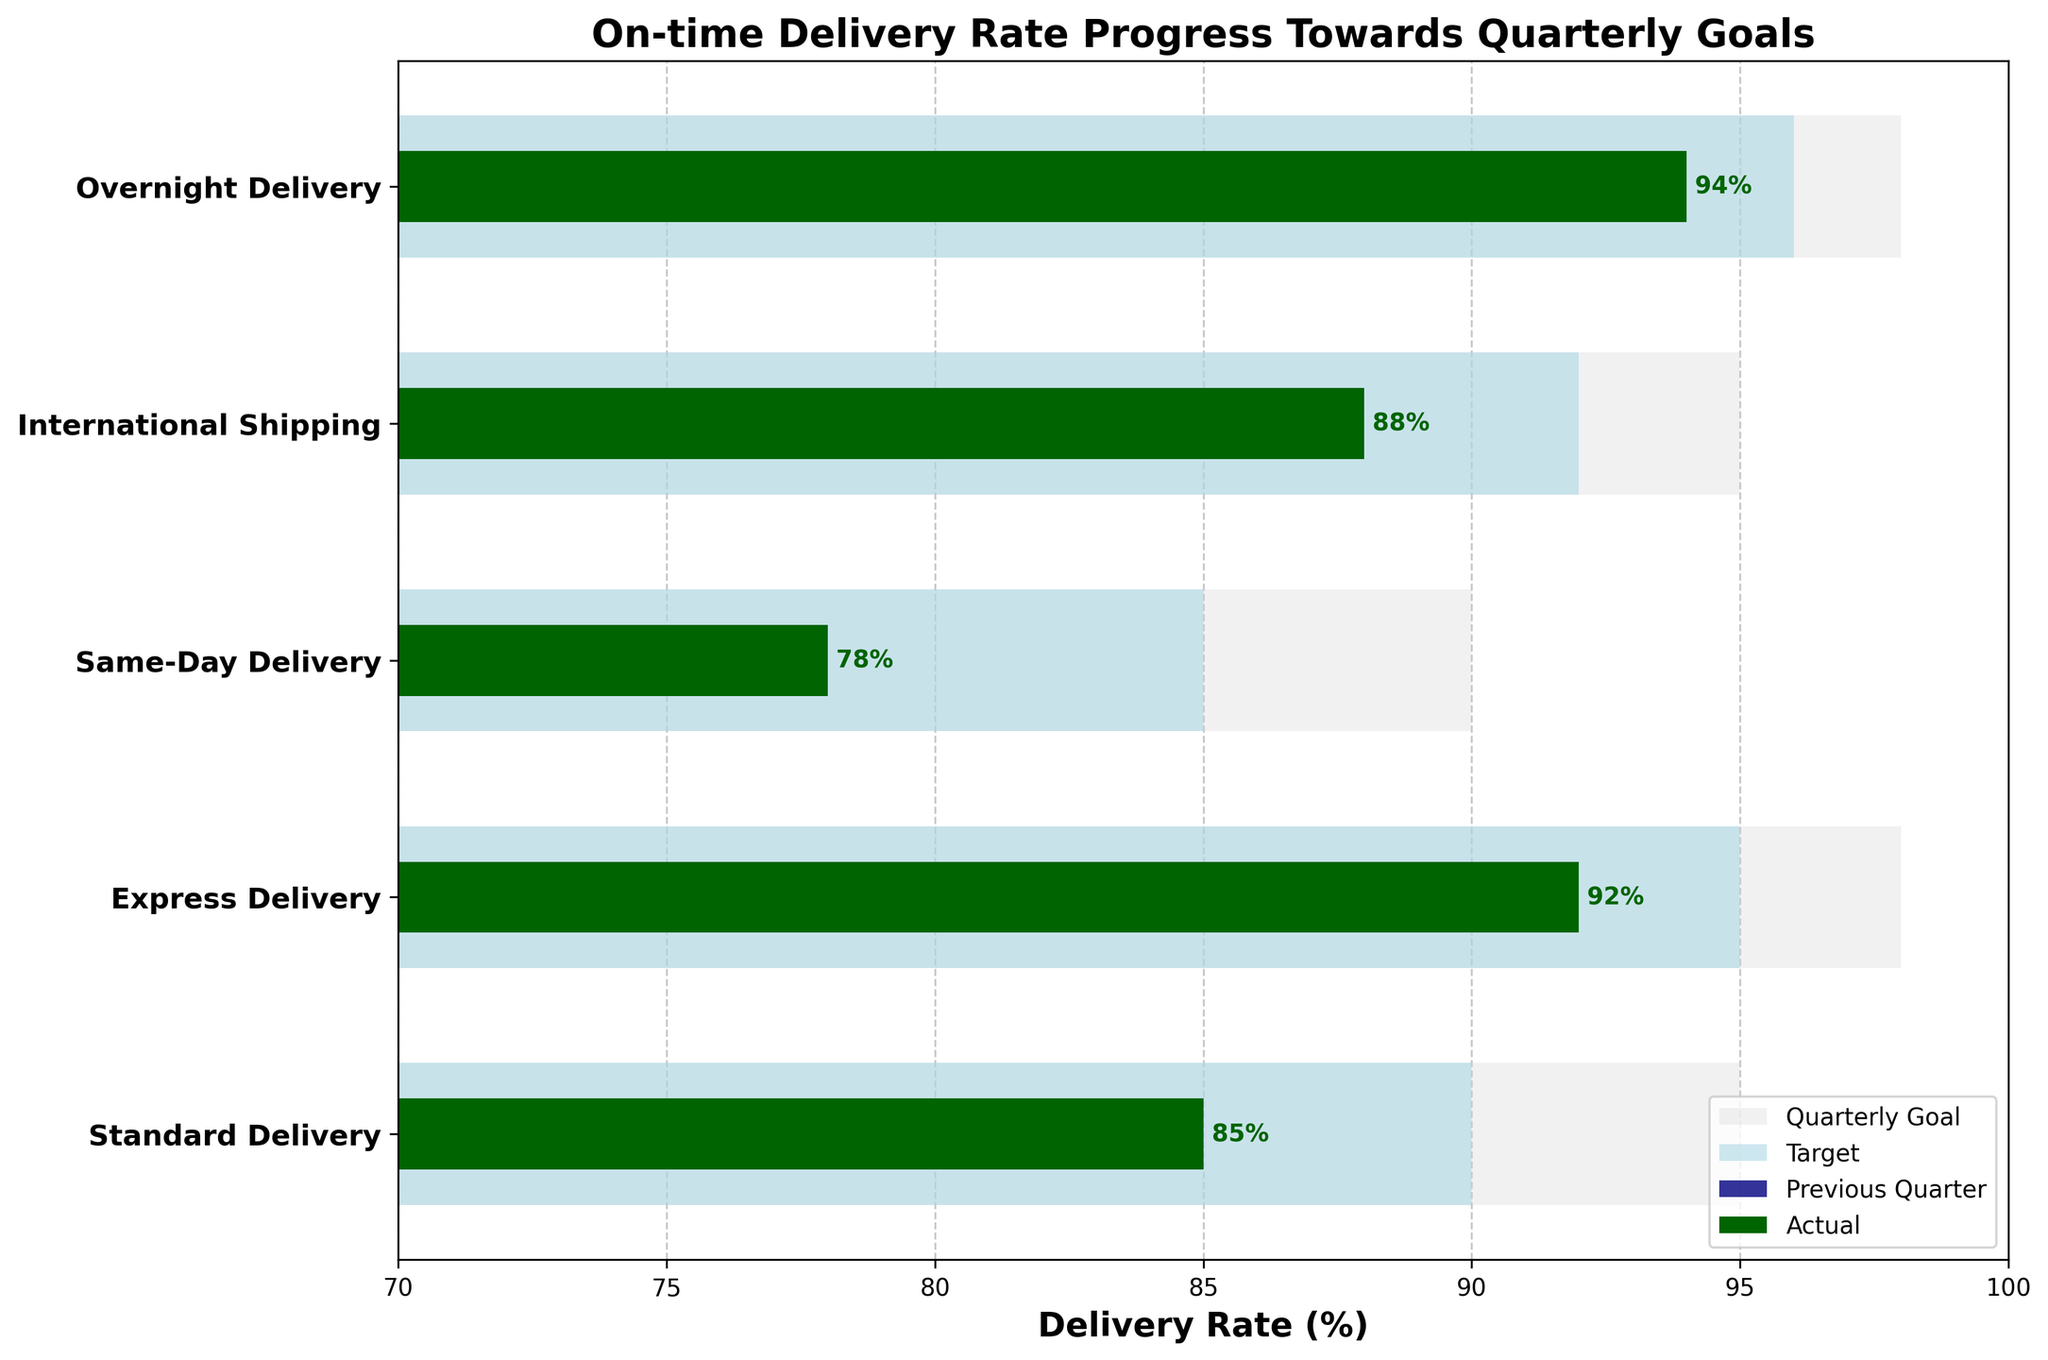What is the title of the figure? The title is usually located at the top of the figure, and in this case, it reads "On-time Delivery Rate Progress Towards Quarterly Goals".
Answer: On-time Delivery Rate Progress Towards Quarterly Goals Which service level has the highest actual on-time delivery rate? By looking at the 'Actual' green bars, the one that extends furthest to the right represents the highest rate. For instance, "Overnight Delivery" appears to have the highest actual on-time rate.
Answer: Overnight Delivery What is the actual on-time delivery rate for Same-Day Delivery? The actual delivery rate for Same-Day Delivery can be found next to its respective green bar labeled on the plot. It typically shows the percentage value. It's labeled as "78%".
Answer: 78% How does the previous quarter's performance of International Shipping compare with its target? Compare the navy bar (Previous Quarter) and the light blue bar (Target) for "International Shipping". The target is 92%, and the previous quarter's rate is 86%.
Answer: Previous quarter is 6% lower than the target Which service level met or exceeded its target on-time delivery rate? Compare all 'Actual' values (in green) with their 'Target' values (in light blue). "Overnight Delivery" with an actual rate of 94% exceeds the target of 96%.
Answer: None What is the difference between the Quarterly Goal and the Actual rate for Standard Delivery? The Quarterly Goal for Standard Delivery is 95%, while the Actual rate is 85%. Subtract the Actual from the Quarterly Goal: 95% - 85% = 10%.
Answer: 10% What is the average on-time delivery rate across all service levels for the Previous Quarter? Add the previous quarter rates (82, 89, 75, 86, 91) and divide by 5: (82 + 89 + 75 + 86 + 91) / 5 = 84.6%.
Answer: 84.6% Which service level has the largest gap between its actual delivery rate and the quarterly goal? Calculate the difference for each service level between Quarterly Goal and Actual, then find the maximum. For "Same-Day Delivery," the gap is 90% - 78% = 12%, which is the largest.
Answer: Same-Day Delivery How many service levels have an actual delivery rate below 90%? Count the number of Actual rates (green bars) that are below 90%: Standard Delivery (85%), Same-Day Delivery (78%), and International Shipping (88%). There are three such service levels.
Answer: 3 